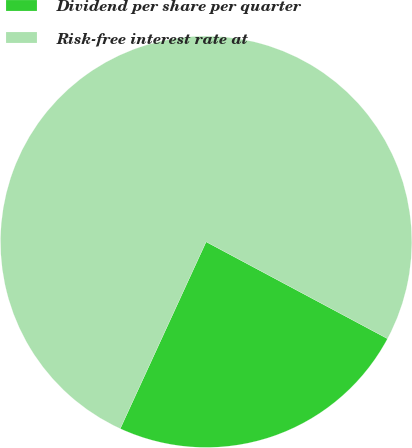Convert chart. <chart><loc_0><loc_0><loc_500><loc_500><pie_chart><fcel>Dividend per share per quarter<fcel>Risk-free interest rate at<nl><fcel>24.05%<fcel>75.95%<nl></chart> 